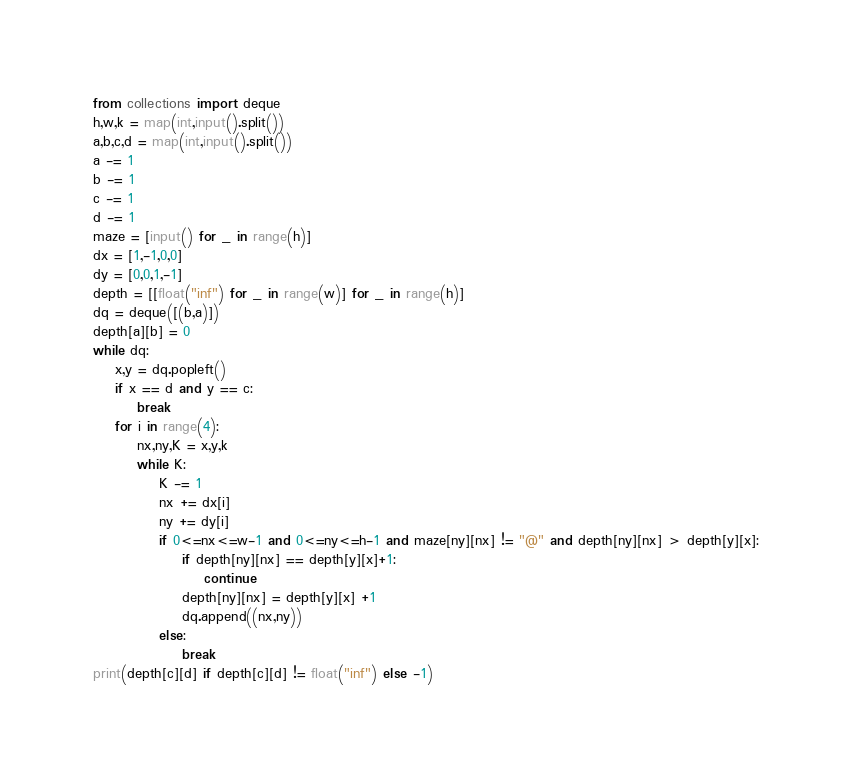<code> <loc_0><loc_0><loc_500><loc_500><_Python_>from collections import deque
h,w,k = map(int,input().split())
a,b,c,d = map(int,input().split())
a -= 1
b -= 1
c -= 1
d -= 1
maze = [input() for _ in range(h)]
dx = [1,-1,0,0]
dy = [0,0,1,-1]
depth = [[float("inf") for _ in range(w)] for _ in range(h)]
dq = deque([(b,a)])
depth[a][b] = 0
while dq:
    x,y = dq.popleft()
    if x == d and y == c:
        break
    for i in range(4):
        nx,ny,K = x,y,k
        while K:
            K -= 1
            nx += dx[i]
            ny += dy[i]
            if 0<=nx<=w-1 and 0<=ny<=h-1 and maze[ny][nx] != "@" and depth[ny][nx] > depth[y][x]:
                if depth[ny][nx] == depth[y][x]+1:
                    continue
                depth[ny][nx] = depth[y][x] +1
                dq.append((nx,ny))
            else:
                break
print(depth[c][d] if depth[c][d] != float("inf") else -1)</code> 